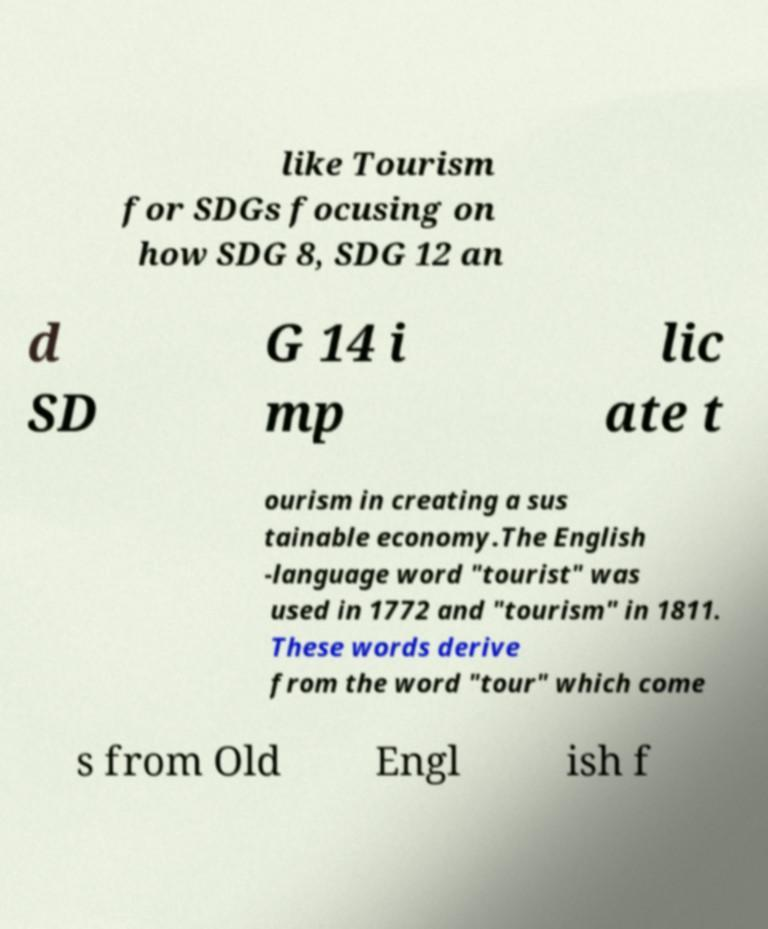Please identify and transcribe the text found in this image. like Tourism for SDGs focusing on how SDG 8, SDG 12 an d SD G 14 i mp lic ate t ourism in creating a sus tainable economy.The English -language word "tourist" was used in 1772 and "tourism" in 1811. These words derive from the word "tour" which come s from Old Engl ish f 